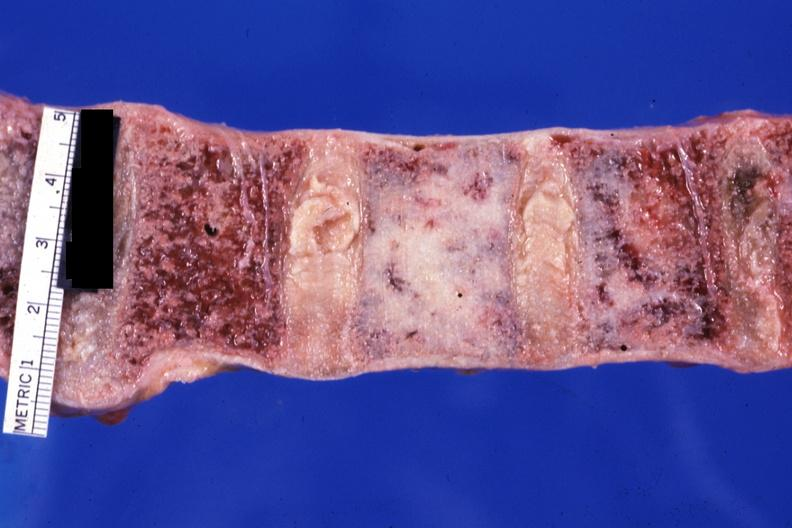s this a case of prostatic carcinoma?
Answer the question using a single word or phrase. Yes 